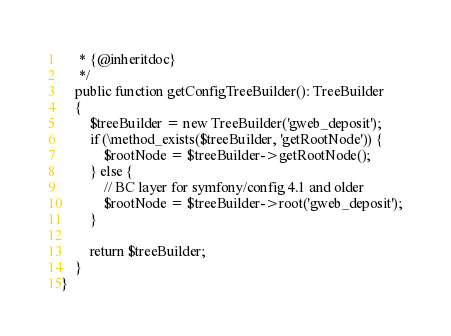Convert code to text. <code><loc_0><loc_0><loc_500><loc_500><_PHP_>     * {@inheritdoc}
     */
    public function getConfigTreeBuilder(): TreeBuilder
    {
        $treeBuilder = new TreeBuilder('gweb_deposit');
        if (\method_exists($treeBuilder, 'getRootNode')) {
            $rootNode = $treeBuilder->getRootNode();
        } else {
            // BC layer for symfony/config 4.1 and older
            $rootNode = $treeBuilder->root('gweb_deposit');
        }

        return $treeBuilder;
    }
}
</code> 